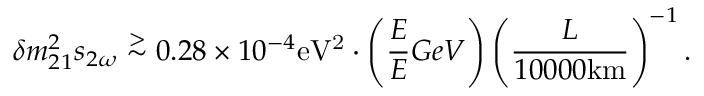<formula> <loc_0><loc_0><loc_500><loc_500>\delta m _ { 2 1 } ^ { 2 } s _ { 2 \omega } \stackrel { > } { \sim } 0 . 2 8 \times 1 0 ^ { - 4 } e V ^ { 2 } \cdot \left ( \frac { E } { E } { G e V } \right ) \left ( \frac { L } { 1 0 0 0 0 k m } \right ) ^ { - 1 } .</formula> 